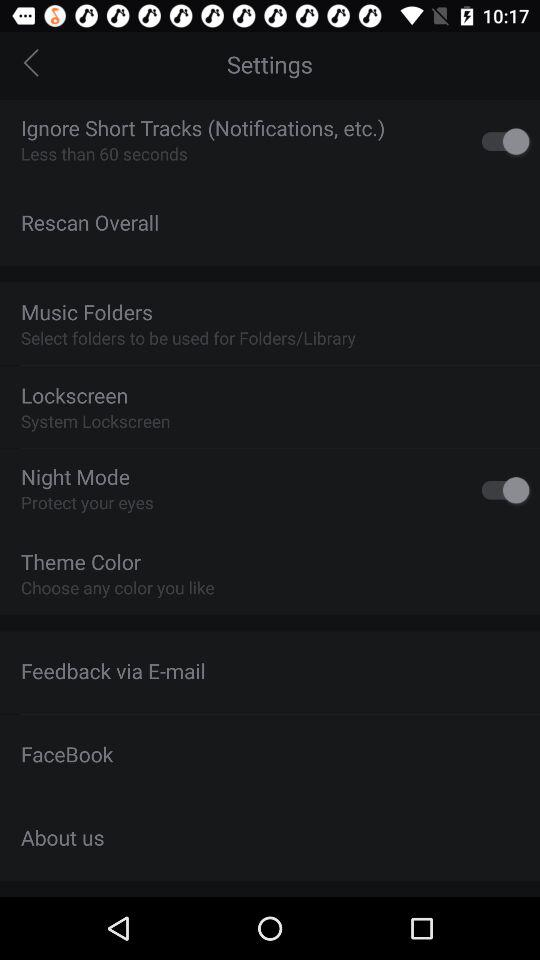How many items have a switch?
Answer the question using a single word or phrase. 2 